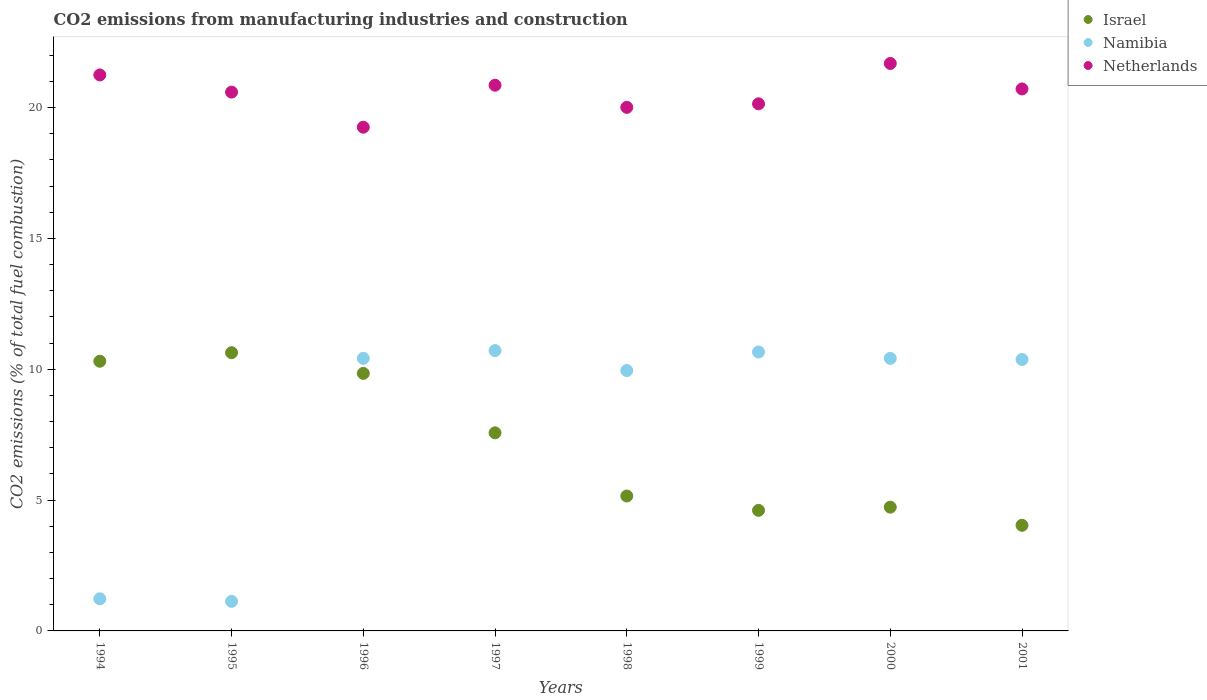How many different coloured dotlines are there?
Offer a terse response. 3. What is the amount of CO2 emitted in Netherlands in 2001?
Your answer should be very brief. 20.71. Across all years, what is the maximum amount of CO2 emitted in Israel?
Ensure brevity in your answer.  10.63. Across all years, what is the minimum amount of CO2 emitted in Israel?
Provide a short and direct response. 4.04. In which year was the amount of CO2 emitted in Israel maximum?
Offer a very short reply. 1995. What is the total amount of CO2 emitted in Israel in the graph?
Provide a succinct answer. 56.88. What is the difference between the amount of CO2 emitted in Israel in 1996 and that in 1999?
Your answer should be compact. 5.23. What is the difference between the amount of CO2 emitted in Namibia in 1995 and the amount of CO2 emitted in Netherlands in 1999?
Give a very brief answer. -19.01. What is the average amount of CO2 emitted in Israel per year?
Ensure brevity in your answer.  7.11. In the year 1997, what is the difference between the amount of CO2 emitted in Namibia and amount of CO2 emitted in Israel?
Ensure brevity in your answer.  3.14. What is the ratio of the amount of CO2 emitted in Namibia in 1995 to that in 2001?
Keep it short and to the point. 0.11. What is the difference between the highest and the second highest amount of CO2 emitted in Israel?
Your answer should be very brief. 0.33. What is the difference between the highest and the lowest amount of CO2 emitted in Netherlands?
Offer a terse response. 2.44. In how many years, is the amount of CO2 emitted in Israel greater than the average amount of CO2 emitted in Israel taken over all years?
Your answer should be very brief. 4. Is it the case that in every year, the sum of the amount of CO2 emitted in Netherlands and amount of CO2 emitted in Namibia  is greater than the amount of CO2 emitted in Israel?
Keep it short and to the point. Yes. Does the amount of CO2 emitted in Namibia monotonically increase over the years?
Your response must be concise. No. How many years are there in the graph?
Your answer should be compact. 8. Does the graph contain any zero values?
Your response must be concise. No. Where does the legend appear in the graph?
Provide a short and direct response. Top right. How many legend labels are there?
Make the answer very short. 3. What is the title of the graph?
Your answer should be very brief. CO2 emissions from manufacturing industries and construction. Does "South Sudan" appear as one of the legend labels in the graph?
Provide a succinct answer. No. What is the label or title of the Y-axis?
Offer a very short reply. CO2 emissions (% of total fuel combustion). What is the CO2 emissions (% of total fuel combustion) of Israel in 1994?
Make the answer very short. 10.31. What is the CO2 emissions (% of total fuel combustion) in Namibia in 1994?
Make the answer very short. 1.23. What is the CO2 emissions (% of total fuel combustion) in Netherlands in 1994?
Your response must be concise. 21.25. What is the CO2 emissions (% of total fuel combustion) of Israel in 1995?
Give a very brief answer. 10.63. What is the CO2 emissions (% of total fuel combustion) of Namibia in 1995?
Keep it short and to the point. 1.13. What is the CO2 emissions (% of total fuel combustion) in Netherlands in 1995?
Your answer should be very brief. 20.59. What is the CO2 emissions (% of total fuel combustion) in Israel in 1996?
Offer a very short reply. 9.84. What is the CO2 emissions (% of total fuel combustion) in Namibia in 1996?
Provide a short and direct response. 10.42. What is the CO2 emissions (% of total fuel combustion) of Netherlands in 1996?
Keep it short and to the point. 19.25. What is the CO2 emissions (% of total fuel combustion) of Israel in 1997?
Offer a very short reply. 7.57. What is the CO2 emissions (% of total fuel combustion) in Namibia in 1997?
Provide a succinct answer. 10.71. What is the CO2 emissions (% of total fuel combustion) in Netherlands in 1997?
Your answer should be compact. 20.86. What is the CO2 emissions (% of total fuel combustion) in Israel in 1998?
Keep it short and to the point. 5.16. What is the CO2 emissions (% of total fuel combustion) in Namibia in 1998?
Offer a terse response. 9.95. What is the CO2 emissions (% of total fuel combustion) of Netherlands in 1998?
Offer a terse response. 20.01. What is the CO2 emissions (% of total fuel combustion) in Israel in 1999?
Your answer should be very brief. 4.61. What is the CO2 emissions (% of total fuel combustion) of Namibia in 1999?
Give a very brief answer. 10.66. What is the CO2 emissions (% of total fuel combustion) in Netherlands in 1999?
Keep it short and to the point. 20.14. What is the CO2 emissions (% of total fuel combustion) in Israel in 2000?
Your answer should be compact. 4.73. What is the CO2 emissions (% of total fuel combustion) of Namibia in 2000?
Ensure brevity in your answer.  10.42. What is the CO2 emissions (% of total fuel combustion) of Netherlands in 2000?
Keep it short and to the point. 21.69. What is the CO2 emissions (% of total fuel combustion) in Israel in 2001?
Give a very brief answer. 4.04. What is the CO2 emissions (% of total fuel combustion) in Namibia in 2001?
Make the answer very short. 10.37. What is the CO2 emissions (% of total fuel combustion) in Netherlands in 2001?
Make the answer very short. 20.71. Across all years, what is the maximum CO2 emissions (% of total fuel combustion) of Israel?
Keep it short and to the point. 10.63. Across all years, what is the maximum CO2 emissions (% of total fuel combustion) in Namibia?
Offer a terse response. 10.71. Across all years, what is the maximum CO2 emissions (% of total fuel combustion) of Netherlands?
Ensure brevity in your answer.  21.69. Across all years, what is the minimum CO2 emissions (% of total fuel combustion) in Israel?
Ensure brevity in your answer.  4.04. Across all years, what is the minimum CO2 emissions (% of total fuel combustion) of Namibia?
Give a very brief answer. 1.13. Across all years, what is the minimum CO2 emissions (% of total fuel combustion) of Netherlands?
Offer a terse response. 19.25. What is the total CO2 emissions (% of total fuel combustion) in Israel in the graph?
Your answer should be compact. 56.88. What is the total CO2 emissions (% of total fuel combustion) in Namibia in the graph?
Your response must be concise. 64.89. What is the total CO2 emissions (% of total fuel combustion) in Netherlands in the graph?
Ensure brevity in your answer.  164.5. What is the difference between the CO2 emissions (% of total fuel combustion) of Israel in 1994 and that in 1995?
Provide a succinct answer. -0.33. What is the difference between the CO2 emissions (% of total fuel combustion) of Namibia in 1994 and that in 1995?
Your answer should be very brief. 0.1. What is the difference between the CO2 emissions (% of total fuel combustion) in Netherlands in 1994 and that in 1995?
Give a very brief answer. 0.66. What is the difference between the CO2 emissions (% of total fuel combustion) in Israel in 1994 and that in 1996?
Your response must be concise. 0.46. What is the difference between the CO2 emissions (% of total fuel combustion) in Namibia in 1994 and that in 1996?
Your answer should be very brief. -9.19. What is the difference between the CO2 emissions (% of total fuel combustion) of Netherlands in 1994 and that in 1996?
Offer a very short reply. 2. What is the difference between the CO2 emissions (% of total fuel combustion) in Israel in 1994 and that in 1997?
Offer a very short reply. 2.74. What is the difference between the CO2 emissions (% of total fuel combustion) of Namibia in 1994 and that in 1997?
Make the answer very short. -9.49. What is the difference between the CO2 emissions (% of total fuel combustion) of Netherlands in 1994 and that in 1997?
Provide a succinct answer. 0.39. What is the difference between the CO2 emissions (% of total fuel combustion) in Israel in 1994 and that in 1998?
Ensure brevity in your answer.  5.15. What is the difference between the CO2 emissions (% of total fuel combustion) in Namibia in 1994 and that in 1998?
Ensure brevity in your answer.  -8.72. What is the difference between the CO2 emissions (% of total fuel combustion) in Netherlands in 1994 and that in 1998?
Your answer should be very brief. 1.24. What is the difference between the CO2 emissions (% of total fuel combustion) of Israel in 1994 and that in 1999?
Give a very brief answer. 5.7. What is the difference between the CO2 emissions (% of total fuel combustion) of Namibia in 1994 and that in 1999?
Keep it short and to the point. -9.43. What is the difference between the CO2 emissions (% of total fuel combustion) of Netherlands in 1994 and that in 1999?
Your response must be concise. 1.1. What is the difference between the CO2 emissions (% of total fuel combustion) in Israel in 1994 and that in 2000?
Your answer should be compact. 5.58. What is the difference between the CO2 emissions (% of total fuel combustion) of Namibia in 1994 and that in 2000?
Provide a succinct answer. -9.19. What is the difference between the CO2 emissions (% of total fuel combustion) of Netherlands in 1994 and that in 2000?
Your answer should be compact. -0.44. What is the difference between the CO2 emissions (% of total fuel combustion) of Israel in 1994 and that in 2001?
Make the answer very short. 6.27. What is the difference between the CO2 emissions (% of total fuel combustion) of Namibia in 1994 and that in 2001?
Keep it short and to the point. -9.15. What is the difference between the CO2 emissions (% of total fuel combustion) in Netherlands in 1994 and that in 2001?
Ensure brevity in your answer.  0.54. What is the difference between the CO2 emissions (% of total fuel combustion) in Israel in 1995 and that in 1996?
Make the answer very short. 0.79. What is the difference between the CO2 emissions (% of total fuel combustion) in Namibia in 1995 and that in 1996?
Ensure brevity in your answer.  -9.29. What is the difference between the CO2 emissions (% of total fuel combustion) of Netherlands in 1995 and that in 1996?
Offer a very short reply. 1.34. What is the difference between the CO2 emissions (% of total fuel combustion) in Israel in 1995 and that in 1997?
Offer a terse response. 3.06. What is the difference between the CO2 emissions (% of total fuel combustion) of Namibia in 1995 and that in 1997?
Give a very brief answer. -9.58. What is the difference between the CO2 emissions (% of total fuel combustion) in Netherlands in 1995 and that in 1997?
Ensure brevity in your answer.  -0.26. What is the difference between the CO2 emissions (% of total fuel combustion) in Israel in 1995 and that in 1998?
Provide a short and direct response. 5.48. What is the difference between the CO2 emissions (% of total fuel combustion) of Namibia in 1995 and that in 1998?
Offer a terse response. -8.82. What is the difference between the CO2 emissions (% of total fuel combustion) in Netherlands in 1995 and that in 1998?
Ensure brevity in your answer.  0.58. What is the difference between the CO2 emissions (% of total fuel combustion) in Israel in 1995 and that in 1999?
Your answer should be very brief. 6.03. What is the difference between the CO2 emissions (% of total fuel combustion) of Namibia in 1995 and that in 1999?
Keep it short and to the point. -9.53. What is the difference between the CO2 emissions (% of total fuel combustion) in Netherlands in 1995 and that in 1999?
Provide a succinct answer. 0.45. What is the difference between the CO2 emissions (% of total fuel combustion) in Israel in 1995 and that in 2000?
Offer a terse response. 5.9. What is the difference between the CO2 emissions (% of total fuel combustion) of Namibia in 1995 and that in 2000?
Keep it short and to the point. -9.29. What is the difference between the CO2 emissions (% of total fuel combustion) in Netherlands in 1995 and that in 2000?
Make the answer very short. -1.09. What is the difference between the CO2 emissions (% of total fuel combustion) of Israel in 1995 and that in 2001?
Keep it short and to the point. 6.6. What is the difference between the CO2 emissions (% of total fuel combustion) in Namibia in 1995 and that in 2001?
Ensure brevity in your answer.  -9.24. What is the difference between the CO2 emissions (% of total fuel combustion) of Netherlands in 1995 and that in 2001?
Your answer should be very brief. -0.12. What is the difference between the CO2 emissions (% of total fuel combustion) in Israel in 1996 and that in 1997?
Offer a terse response. 2.27. What is the difference between the CO2 emissions (% of total fuel combustion) of Namibia in 1996 and that in 1997?
Your response must be concise. -0.3. What is the difference between the CO2 emissions (% of total fuel combustion) of Netherlands in 1996 and that in 1997?
Make the answer very short. -1.6. What is the difference between the CO2 emissions (% of total fuel combustion) of Israel in 1996 and that in 1998?
Your response must be concise. 4.69. What is the difference between the CO2 emissions (% of total fuel combustion) of Namibia in 1996 and that in 1998?
Offer a very short reply. 0.47. What is the difference between the CO2 emissions (% of total fuel combustion) in Netherlands in 1996 and that in 1998?
Make the answer very short. -0.76. What is the difference between the CO2 emissions (% of total fuel combustion) of Israel in 1996 and that in 1999?
Provide a succinct answer. 5.23. What is the difference between the CO2 emissions (% of total fuel combustion) in Namibia in 1996 and that in 1999?
Your response must be concise. -0.24. What is the difference between the CO2 emissions (% of total fuel combustion) in Netherlands in 1996 and that in 1999?
Ensure brevity in your answer.  -0.89. What is the difference between the CO2 emissions (% of total fuel combustion) of Israel in 1996 and that in 2000?
Offer a very short reply. 5.11. What is the difference between the CO2 emissions (% of total fuel combustion) in Netherlands in 1996 and that in 2000?
Offer a terse response. -2.44. What is the difference between the CO2 emissions (% of total fuel combustion) of Israel in 1996 and that in 2001?
Your response must be concise. 5.81. What is the difference between the CO2 emissions (% of total fuel combustion) in Namibia in 1996 and that in 2001?
Ensure brevity in your answer.  0.04. What is the difference between the CO2 emissions (% of total fuel combustion) in Netherlands in 1996 and that in 2001?
Give a very brief answer. -1.46. What is the difference between the CO2 emissions (% of total fuel combustion) in Israel in 1997 and that in 1998?
Make the answer very short. 2.41. What is the difference between the CO2 emissions (% of total fuel combustion) in Namibia in 1997 and that in 1998?
Give a very brief answer. 0.76. What is the difference between the CO2 emissions (% of total fuel combustion) in Netherlands in 1997 and that in 1998?
Give a very brief answer. 0.85. What is the difference between the CO2 emissions (% of total fuel combustion) of Israel in 1997 and that in 1999?
Offer a terse response. 2.96. What is the difference between the CO2 emissions (% of total fuel combustion) in Namibia in 1997 and that in 1999?
Ensure brevity in your answer.  0.05. What is the difference between the CO2 emissions (% of total fuel combustion) of Netherlands in 1997 and that in 1999?
Provide a short and direct response. 0.71. What is the difference between the CO2 emissions (% of total fuel combustion) of Israel in 1997 and that in 2000?
Your response must be concise. 2.84. What is the difference between the CO2 emissions (% of total fuel combustion) in Namibia in 1997 and that in 2000?
Ensure brevity in your answer.  0.3. What is the difference between the CO2 emissions (% of total fuel combustion) of Netherlands in 1997 and that in 2000?
Your response must be concise. -0.83. What is the difference between the CO2 emissions (% of total fuel combustion) of Israel in 1997 and that in 2001?
Ensure brevity in your answer.  3.53. What is the difference between the CO2 emissions (% of total fuel combustion) in Namibia in 1997 and that in 2001?
Make the answer very short. 0.34. What is the difference between the CO2 emissions (% of total fuel combustion) in Netherlands in 1997 and that in 2001?
Your answer should be very brief. 0.14. What is the difference between the CO2 emissions (% of total fuel combustion) in Israel in 1998 and that in 1999?
Your answer should be very brief. 0.55. What is the difference between the CO2 emissions (% of total fuel combustion) in Namibia in 1998 and that in 1999?
Your answer should be very brief. -0.71. What is the difference between the CO2 emissions (% of total fuel combustion) in Netherlands in 1998 and that in 1999?
Offer a terse response. -0.14. What is the difference between the CO2 emissions (% of total fuel combustion) in Israel in 1998 and that in 2000?
Make the answer very short. 0.43. What is the difference between the CO2 emissions (% of total fuel combustion) in Namibia in 1998 and that in 2000?
Your answer should be very brief. -0.47. What is the difference between the CO2 emissions (% of total fuel combustion) of Netherlands in 1998 and that in 2000?
Provide a succinct answer. -1.68. What is the difference between the CO2 emissions (% of total fuel combustion) in Israel in 1998 and that in 2001?
Ensure brevity in your answer.  1.12. What is the difference between the CO2 emissions (% of total fuel combustion) in Namibia in 1998 and that in 2001?
Provide a succinct answer. -0.42. What is the difference between the CO2 emissions (% of total fuel combustion) in Netherlands in 1998 and that in 2001?
Offer a terse response. -0.7. What is the difference between the CO2 emissions (% of total fuel combustion) of Israel in 1999 and that in 2000?
Keep it short and to the point. -0.12. What is the difference between the CO2 emissions (% of total fuel combustion) of Namibia in 1999 and that in 2000?
Keep it short and to the point. 0.24. What is the difference between the CO2 emissions (% of total fuel combustion) in Netherlands in 1999 and that in 2000?
Your answer should be compact. -1.54. What is the difference between the CO2 emissions (% of total fuel combustion) of Israel in 1999 and that in 2001?
Keep it short and to the point. 0.57. What is the difference between the CO2 emissions (% of total fuel combustion) of Namibia in 1999 and that in 2001?
Your response must be concise. 0.29. What is the difference between the CO2 emissions (% of total fuel combustion) of Netherlands in 1999 and that in 2001?
Give a very brief answer. -0.57. What is the difference between the CO2 emissions (% of total fuel combustion) in Israel in 2000 and that in 2001?
Your answer should be very brief. 0.69. What is the difference between the CO2 emissions (% of total fuel combustion) in Namibia in 2000 and that in 2001?
Offer a terse response. 0.04. What is the difference between the CO2 emissions (% of total fuel combustion) of Netherlands in 2000 and that in 2001?
Keep it short and to the point. 0.97. What is the difference between the CO2 emissions (% of total fuel combustion) in Israel in 1994 and the CO2 emissions (% of total fuel combustion) in Namibia in 1995?
Provide a succinct answer. 9.18. What is the difference between the CO2 emissions (% of total fuel combustion) in Israel in 1994 and the CO2 emissions (% of total fuel combustion) in Netherlands in 1995?
Make the answer very short. -10.29. What is the difference between the CO2 emissions (% of total fuel combustion) of Namibia in 1994 and the CO2 emissions (% of total fuel combustion) of Netherlands in 1995?
Offer a very short reply. -19.36. What is the difference between the CO2 emissions (% of total fuel combustion) of Israel in 1994 and the CO2 emissions (% of total fuel combustion) of Namibia in 1996?
Ensure brevity in your answer.  -0.11. What is the difference between the CO2 emissions (% of total fuel combustion) of Israel in 1994 and the CO2 emissions (% of total fuel combustion) of Netherlands in 1996?
Give a very brief answer. -8.94. What is the difference between the CO2 emissions (% of total fuel combustion) in Namibia in 1994 and the CO2 emissions (% of total fuel combustion) in Netherlands in 1996?
Offer a very short reply. -18.02. What is the difference between the CO2 emissions (% of total fuel combustion) in Israel in 1994 and the CO2 emissions (% of total fuel combustion) in Namibia in 1997?
Provide a succinct answer. -0.41. What is the difference between the CO2 emissions (% of total fuel combustion) of Israel in 1994 and the CO2 emissions (% of total fuel combustion) of Netherlands in 1997?
Keep it short and to the point. -10.55. What is the difference between the CO2 emissions (% of total fuel combustion) in Namibia in 1994 and the CO2 emissions (% of total fuel combustion) in Netherlands in 1997?
Your answer should be very brief. -19.63. What is the difference between the CO2 emissions (% of total fuel combustion) of Israel in 1994 and the CO2 emissions (% of total fuel combustion) of Namibia in 1998?
Ensure brevity in your answer.  0.36. What is the difference between the CO2 emissions (% of total fuel combustion) in Israel in 1994 and the CO2 emissions (% of total fuel combustion) in Netherlands in 1998?
Offer a terse response. -9.7. What is the difference between the CO2 emissions (% of total fuel combustion) of Namibia in 1994 and the CO2 emissions (% of total fuel combustion) of Netherlands in 1998?
Make the answer very short. -18.78. What is the difference between the CO2 emissions (% of total fuel combustion) in Israel in 1994 and the CO2 emissions (% of total fuel combustion) in Namibia in 1999?
Your answer should be compact. -0.35. What is the difference between the CO2 emissions (% of total fuel combustion) in Israel in 1994 and the CO2 emissions (% of total fuel combustion) in Netherlands in 1999?
Give a very brief answer. -9.84. What is the difference between the CO2 emissions (% of total fuel combustion) of Namibia in 1994 and the CO2 emissions (% of total fuel combustion) of Netherlands in 1999?
Keep it short and to the point. -18.92. What is the difference between the CO2 emissions (% of total fuel combustion) of Israel in 1994 and the CO2 emissions (% of total fuel combustion) of Namibia in 2000?
Your answer should be very brief. -0.11. What is the difference between the CO2 emissions (% of total fuel combustion) of Israel in 1994 and the CO2 emissions (% of total fuel combustion) of Netherlands in 2000?
Provide a short and direct response. -11.38. What is the difference between the CO2 emissions (% of total fuel combustion) of Namibia in 1994 and the CO2 emissions (% of total fuel combustion) of Netherlands in 2000?
Offer a very short reply. -20.46. What is the difference between the CO2 emissions (% of total fuel combustion) of Israel in 1994 and the CO2 emissions (% of total fuel combustion) of Namibia in 2001?
Provide a short and direct response. -0.07. What is the difference between the CO2 emissions (% of total fuel combustion) in Israel in 1994 and the CO2 emissions (% of total fuel combustion) in Netherlands in 2001?
Provide a short and direct response. -10.41. What is the difference between the CO2 emissions (% of total fuel combustion) of Namibia in 1994 and the CO2 emissions (% of total fuel combustion) of Netherlands in 2001?
Offer a terse response. -19.49. What is the difference between the CO2 emissions (% of total fuel combustion) in Israel in 1995 and the CO2 emissions (% of total fuel combustion) in Namibia in 1996?
Give a very brief answer. 0.22. What is the difference between the CO2 emissions (% of total fuel combustion) of Israel in 1995 and the CO2 emissions (% of total fuel combustion) of Netherlands in 1996?
Your answer should be very brief. -8.62. What is the difference between the CO2 emissions (% of total fuel combustion) in Namibia in 1995 and the CO2 emissions (% of total fuel combustion) in Netherlands in 1996?
Provide a short and direct response. -18.12. What is the difference between the CO2 emissions (% of total fuel combustion) in Israel in 1995 and the CO2 emissions (% of total fuel combustion) in Namibia in 1997?
Your answer should be very brief. -0.08. What is the difference between the CO2 emissions (% of total fuel combustion) in Israel in 1995 and the CO2 emissions (% of total fuel combustion) in Netherlands in 1997?
Your answer should be compact. -10.22. What is the difference between the CO2 emissions (% of total fuel combustion) of Namibia in 1995 and the CO2 emissions (% of total fuel combustion) of Netherlands in 1997?
Provide a succinct answer. -19.73. What is the difference between the CO2 emissions (% of total fuel combustion) in Israel in 1995 and the CO2 emissions (% of total fuel combustion) in Namibia in 1998?
Keep it short and to the point. 0.68. What is the difference between the CO2 emissions (% of total fuel combustion) of Israel in 1995 and the CO2 emissions (% of total fuel combustion) of Netherlands in 1998?
Your answer should be very brief. -9.38. What is the difference between the CO2 emissions (% of total fuel combustion) in Namibia in 1995 and the CO2 emissions (% of total fuel combustion) in Netherlands in 1998?
Offer a very short reply. -18.88. What is the difference between the CO2 emissions (% of total fuel combustion) of Israel in 1995 and the CO2 emissions (% of total fuel combustion) of Namibia in 1999?
Provide a succinct answer. -0.03. What is the difference between the CO2 emissions (% of total fuel combustion) of Israel in 1995 and the CO2 emissions (% of total fuel combustion) of Netherlands in 1999?
Your response must be concise. -9.51. What is the difference between the CO2 emissions (% of total fuel combustion) of Namibia in 1995 and the CO2 emissions (% of total fuel combustion) of Netherlands in 1999?
Your answer should be very brief. -19.01. What is the difference between the CO2 emissions (% of total fuel combustion) in Israel in 1995 and the CO2 emissions (% of total fuel combustion) in Namibia in 2000?
Your response must be concise. 0.22. What is the difference between the CO2 emissions (% of total fuel combustion) of Israel in 1995 and the CO2 emissions (% of total fuel combustion) of Netherlands in 2000?
Offer a very short reply. -11.05. What is the difference between the CO2 emissions (% of total fuel combustion) in Namibia in 1995 and the CO2 emissions (% of total fuel combustion) in Netherlands in 2000?
Ensure brevity in your answer.  -20.56. What is the difference between the CO2 emissions (% of total fuel combustion) in Israel in 1995 and the CO2 emissions (% of total fuel combustion) in Namibia in 2001?
Provide a short and direct response. 0.26. What is the difference between the CO2 emissions (% of total fuel combustion) in Israel in 1995 and the CO2 emissions (% of total fuel combustion) in Netherlands in 2001?
Your answer should be very brief. -10.08. What is the difference between the CO2 emissions (% of total fuel combustion) of Namibia in 1995 and the CO2 emissions (% of total fuel combustion) of Netherlands in 2001?
Ensure brevity in your answer.  -19.58. What is the difference between the CO2 emissions (% of total fuel combustion) in Israel in 1996 and the CO2 emissions (% of total fuel combustion) in Namibia in 1997?
Offer a terse response. -0.87. What is the difference between the CO2 emissions (% of total fuel combustion) of Israel in 1996 and the CO2 emissions (% of total fuel combustion) of Netherlands in 1997?
Your answer should be very brief. -11.01. What is the difference between the CO2 emissions (% of total fuel combustion) of Namibia in 1996 and the CO2 emissions (% of total fuel combustion) of Netherlands in 1997?
Give a very brief answer. -10.44. What is the difference between the CO2 emissions (% of total fuel combustion) in Israel in 1996 and the CO2 emissions (% of total fuel combustion) in Namibia in 1998?
Offer a very short reply. -0.11. What is the difference between the CO2 emissions (% of total fuel combustion) in Israel in 1996 and the CO2 emissions (% of total fuel combustion) in Netherlands in 1998?
Provide a short and direct response. -10.17. What is the difference between the CO2 emissions (% of total fuel combustion) in Namibia in 1996 and the CO2 emissions (% of total fuel combustion) in Netherlands in 1998?
Keep it short and to the point. -9.59. What is the difference between the CO2 emissions (% of total fuel combustion) of Israel in 1996 and the CO2 emissions (% of total fuel combustion) of Namibia in 1999?
Ensure brevity in your answer.  -0.82. What is the difference between the CO2 emissions (% of total fuel combustion) in Israel in 1996 and the CO2 emissions (% of total fuel combustion) in Netherlands in 1999?
Your response must be concise. -10.3. What is the difference between the CO2 emissions (% of total fuel combustion) in Namibia in 1996 and the CO2 emissions (% of total fuel combustion) in Netherlands in 1999?
Provide a short and direct response. -9.73. What is the difference between the CO2 emissions (% of total fuel combustion) of Israel in 1996 and the CO2 emissions (% of total fuel combustion) of Namibia in 2000?
Offer a terse response. -0.57. What is the difference between the CO2 emissions (% of total fuel combustion) in Israel in 1996 and the CO2 emissions (% of total fuel combustion) in Netherlands in 2000?
Provide a short and direct response. -11.84. What is the difference between the CO2 emissions (% of total fuel combustion) of Namibia in 1996 and the CO2 emissions (% of total fuel combustion) of Netherlands in 2000?
Give a very brief answer. -11.27. What is the difference between the CO2 emissions (% of total fuel combustion) in Israel in 1996 and the CO2 emissions (% of total fuel combustion) in Namibia in 2001?
Provide a succinct answer. -0.53. What is the difference between the CO2 emissions (% of total fuel combustion) in Israel in 1996 and the CO2 emissions (% of total fuel combustion) in Netherlands in 2001?
Your answer should be very brief. -10.87. What is the difference between the CO2 emissions (% of total fuel combustion) of Namibia in 1996 and the CO2 emissions (% of total fuel combustion) of Netherlands in 2001?
Offer a terse response. -10.3. What is the difference between the CO2 emissions (% of total fuel combustion) of Israel in 1997 and the CO2 emissions (% of total fuel combustion) of Namibia in 1998?
Offer a very short reply. -2.38. What is the difference between the CO2 emissions (% of total fuel combustion) in Israel in 1997 and the CO2 emissions (% of total fuel combustion) in Netherlands in 1998?
Your answer should be very brief. -12.44. What is the difference between the CO2 emissions (% of total fuel combustion) of Namibia in 1997 and the CO2 emissions (% of total fuel combustion) of Netherlands in 1998?
Provide a succinct answer. -9.29. What is the difference between the CO2 emissions (% of total fuel combustion) in Israel in 1997 and the CO2 emissions (% of total fuel combustion) in Namibia in 1999?
Ensure brevity in your answer.  -3.09. What is the difference between the CO2 emissions (% of total fuel combustion) in Israel in 1997 and the CO2 emissions (% of total fuel combustion) in Netherlands in 1999?
Provide a short and direct response. -12.57. What is the difference between the CO2 emissions (% of total fuel combustion) in Namibia in 1997 and the CO2 emissions (% of total fuel combustion) in Netherlands in 1999?
Provide a short and direct response. -9.43. What is the difference between the CO2 emissions (% of total fuel combustion) of Israel in 1997 and the CO2 emissions (% of total fuel combustion) of Namibia in 2000?
Keep it short and to the point. -2.85. What is the difference between the CO2 emissions (% of total fuel combustion) in Israel in 1997 and the CO2 emissions (% of total fuel combustion) in Netherlands in 2000?
Ensure brevity in your answer.  -14.12. What is the difference between the CO2 emissions (% of total fuel combustion) in Namibia in 1997 and the CO2 emissions (% of total fuel combustion) in Netherlands in 2000?
Your answer should be very brief. -10.97. What is the difference between the CO2 emissions (% of total fuel combustion) of Israel in 1997 and the CO2 emissions (% of total fuel combustion) of Namibia in 2001?
Make the answer very short. -2.8. What is the difference between the CO2 emissions (% of total fuel combustion) in Israel in 1997 and the CO2 emissions (% of total fuel combustion) in Netherlands in 2001?
Give a very brief answer. -13.14. What is the difference between the CO2 emissions (% of total fuel combustion) in Namibia in 1997 and the CO2 emissions (% of total fuel combustion) in Netherlands in 2001?
Offer a very short reply. -10. What is the difference between the CO2 emissions (% of total fuel combustion) of Israel in 1998 and the CO2 emissions (% of total fuel combustion) of Namibia in 1999?
Keep it short and to the point. -5.5. What is the difference between the CO2 emissions (% of total fuel combustion) in Israel in 1998 and the CO2 emissions (% of total fuel combustion) in Netherlands in 1999?
Provide a short and direct response. -14.99. What is the difference between the CO2 emissions (% of total fuel combustion) of Namibia in 1998 and the CO2 emissions (% of total fuel combustion) of Netherlands in 1999?
Your answer should be very brief. -10.19. What is the difference between the CO2 emissions (% of total fuel combustion) of Israel in 1998 and the CO2 emissions (% of total fuel combustion) of Namibia in 2000?
Keep it short and to the point. -5.26. What is the difference between the CO2 emissions (% of total fuel combustion) of Israel in 1998 and the CO2 emissions (% of total fuel combustion) of Netherlands in 2000?
Your answer should be very brief. -16.53. What is the difference between the CO2 emissions (% of total fuel combustion) in Namibia in 1998 and the CO2 emissions (% of total fuel combustion) in Netherlands in 2000?
Make the answer very short. -11.74. What is the difference between the CO2 emissions (% of total fuel combustion) of Israel in 1998 and the CO2 emissions (% of total fuel combustion) of Namibia in 2001?
Keep it short and to the point. -5.22. What is the difference between the CO2 emissions (% of total fuel combustion) in Israel in 1998 and the CO2 emissions (% of total fuel combustion) in Netherlands in 2001?
Your answer should be very brief. -15.56. What is the difference between the CO2 emissions (% of total fuel combustion) of Namibia in 1998 and the CO2 emissions (% of total fuel combustion) of Netherlands in 2001?
Your answer should be compact. -10.76. What is the difference between the CO2 emissions (% of total fuel combustion) in Israel in 1999 and the CO2 emissions (% of total fuel combustion) in Namibia in 2000?
Make the answer very short. -5.81. What is the difference between the CO2 emissions (% of total fuel combustion) in Israel in 1999 and the CO2 emissions (% of total fuel combustion) in Netherlands in 2000?
Your answer should be very brief. -17.08. What is the difference between the CO2 emissions (% of total fuel combustion) of Namibia in 1999 and the CO2 emissions (% of total fuel combustion) of Netherlands in 2000?
Your answer should be compact. -11.03. What is the difference between the CO2 emissions (% of total fuel combustion) in Israel in 1999 and the CO2 emissions (% of total fuel combustion) in Namibia in 2001?
Provide a succinct answer. -5.77. What is the difference between the CO2 emissions (% of total fuel combustion) in Israel in 1999 and the CO2 emissions (% of total fuel combustion) in Netherlands in 2001?
Give a very brief answer. -16.1. What is the difference between the CO2 emissions (% of total fuel combustion) in Namibia in 1999 and the CO2 emissions (% of total fuel combustion) in Netherlands in 2001?
Your response must be concise. -10.05. What is the difference between the CO2 emissions (% of total fuel combustion) in Israel in 2000 and the CO2 emissions (% of total fuel combustion) in Namibia in 2001?
Offer a very short reply. -5.64. What is the difference between the CO2 emissions (% of total fuel combustion) in Israel in 2000 and the CO2 emissions (% of total fuel combustion) in Netherlands in 2001?
Your response must be concise. -15.98. What is the difference between the CO2 emissions (% of total fuel combustion) of Namibia in 2000 and the CO2 emissions (% of total fuel combustion) of Netherlands in 2001?
Offer a terse response. -10.3. What is the average CO2 emissions (% of total fuel combustion) of Israel per year?
Provide a succinct answer. 7.11. What is the average CO2 emissions (% of total fuel combustion) of Namibia per year?
Make the answer very short. 8.11. What is the average CO2 emissions (% of total fuel combustion) of Netherlands per year?
Provide a short and direct response. 20.56. In the year 1994, what is the difference between the CO2 emissions (% of total fuel combustion) of Israel and CO2 emissions (% of total fuel combustion) of Namibia?
Provide a succinct answer. 9.08. In the year 1994, what is the difference between the CO2 emissions (% of total fuel combustion) in Israel and CO2 emissions (% of total fuel combustion) in Netherlands?
Your response must be concise. -10.94. In the year 1994, what is the difference between the CO2 emissions (% of total fuel combustion) in Namibia and CO2 emissions (% of total fuel combustion) in Netherlands?
Make the answer very short. -20.02. In the year 1995, what is the difference between the CO2 emissions (% of total fuel combustion) in Israel and CO2 emissions (% of total fuel combustion) in Namibia?
Your answer should be very brief. 9.5. In the year 1995, what is the difference between the CO2 emissions (% of total fuel combustion) in Israel and CO2 emissions (% of total fuel combustion) in Netherlands?
Offer a very short reply. -9.96. In the year 1995, what is the difference between the CO2 emissions (% of total fuel combustion) of Namibia and CO2 emissions (% of total fuel combustion) of Netherlands?
Ensure brevity in your answer.  -19.46. In the year 1996, what is the difference between the CO2 emissions (% of total fuel combustion) in Israel and CO2 emissions (% of total fuel combustion) in Namibia?
Provide a succinct answer. -0.57. In the year 1996, what is the difference between the CO2 emissions (% of total fuel combustion) of Israel and CO2 emissions (% of total fuel combustion) of Netherlands?
Provide a succinct answer. -9.41. In the year 1996, what is the difference between the CO2 emissions (% of total fuel combustion) of Namibia and CO2 emissions (% of total fuel combustion) of Netherlands?
Make the answer very short. -8.83. In the year 1997, what is the difference between the CO2 emissions (% of total fuel combustion) of Israel and CO2 emissions (% of total fuel combustion) of Namibia?
Give a very brief answer. -3.14. In the year 1997, what is the difference between the CO2 emissions (% of total fuel combustion) of Israel and CO2 emissions (% of total fuel combustion) of Netherlands?
Provide a succinct answer. -13.29. In the year 1997, what is the difference between the CO2 emissions (% of total fuel combustion) in Namibia and CO2 emissions (% of total fuel combustion) in Netherlands?
Your answer should be very brief. -10.14. In the year 1998, what is the difference between the CO2 emissions (% of total fuel combustion) of Israel and CO2 emissions (% of total fuel combustion) of Namibia?
Keep it short and to the point. -4.79. In the year 1998, what is the difference between the CO2 emissions (% of total fuel combustion) of Israel and CO2 emissions (% of total fuel combustion) of Netherlands?
Give a very brief answer. -14.85. In the year 1998, what is the difference between the CO2 emissions (% of total fuel combustion) in Namibia and CO2 emissions (% of total fuel combustion) in Netherlands?
Your answer should be compact. -10.06. In the year 1999, what is the difference between the CO2 emissions (% of total fuel combustion) of Israel and CO2 emissions (% of total fuel combustion) of Namibia?
Provide a succinct answer. -6.05. In the year 1999, what is the difference between the CO2 emissions (% of total fuel combustion) of Israel and CO2 emissions (% of total fuel combustion) of Netherlands?
Make the answer very short. -15.54. In the year 1999, what is the difference between the CO2 emissions (% of total fuel combustion) in Namibia and CO2 emissions (% of total fuel combustion) in Netherlands?
Ensure brevity in your answer.  -9.48. In the year 2000, what is the difference between the CO2 emissions (% of total fuel combustion) of Israel and CO2 emissions (% of total fuel combustion) of Namibia?
Your answer should be compact. -5.69. In the year 2000, what is the difference between the CO2 emissions (% of total fuel combustion) of Israel and CO2 emissions (% of total fuel combustion) of Netherlands?
Your answer should be compact. -16.96. In the year 2000, what is the difference between the CO2 emissions (% of total fuel combustion) of Namibia and CO2 emissions (% of total fuel combustion) of Netherlands?
Your answer should be very brief. -11.27. In the year 2001, what is the difference between the CO2 emissions (% of total fuel combustion) of Israel and CO2 emissions (% of total fuel combustion) of Namibia?
Provide a short and direct response. -6.34. In the year 2001, what is the difference between the CO2 emissions (% of total fuel combustion) in Israel and CO2 emissions (% of total fuel combustion) in Netherlands?
Your response must be concise. -16.68. In the year 2001, what is the difference between the CO2 emissions (% of total fuel combustion) in Namibia and CO2 emissions (% of total fuel combustion) in Netherlands?
Give a very brief answer. -10.34. What is the ratio of the CO2 emissions (% of total fuel combustion) in Israel in 1994 to that in 1995?
Keep it short and to the point. 0.97. What is the ratio of the CO2 emissions (% of total fuel combustion) of Namibia in 1994 to that in 1995?
Your answer should be compact. 1.09. What is the ratio of the CO2 emissions (% of total fuel combustion) of Netherlands in 1994 to that in 1995?
Offer a terse response. 1.03. What is the ratio of the CO2 emissions (% of total fuel combustion) in Israel in 1994 to that in 1996?
Make the answer very short. 1.05. What is the ratio of the CO2 emissions (% of total fuel combustion) of Namibia in 1994 to that in 1996?
Your answer should be compact. 0.12. What is the ratio of the CO2 emissions (% of total fuel combustion) of Netherlands in 1994 to that in 1996?
Your answer should be very brief. 1.1. What is the ratio of the CO2 emissions (% of total fuel combustion) of Israel in 1994 to that in 1997?
Ensure brevity in your answer.  1.36. What is the ratio of the CO2 emissions (% of total fuel combustion) in Namibia in 1994 to that in 1997?
Keep it short and to the point. 0.11. What is the ratio of the CO2 emissions (% of total fuel combustion) in Netherlands in 1994 to that in 1997?
Your answer should be very brief. 1.02. What is the ratio of the CO2 emissions (% of total fuel combustion) of Israel in 1994 to that in 1998?
Make the answer very short. 2. What is the ratio of the CO2 emissions (% of total fuel combustion) in Namibia in 1994 to that in 1998?
Keep it short and to the point. 0.12. What is the ratio of the CO2 emissions (% of total fuel combustion) of Netherlands in 1994 to that in 1998?
Provide a succinct answer. 1.06. What is the ratio of the CO2 emissions (% of total fuel combustion) in Israel in 1994 to that in 1999?
Your answer should be compact. 2.24. What is the ratio of the CO2 emissions (% of total fuel combustion) of Namibia in 1994 to that in 1999?
Your answer should be compact. 0.12. What is the ratio of the CO2 emissions (% of total fuel combustion) of Netherlands in 1994 to that in 1999?
Your answer should be very brief. 1.05. What is the ratio of the CO2 emissions (% of total fuel combustion) of Israel in 1994 to that in 2000?
Give a very brief answer. 2.18. What is the ratio of the CO2 emissions (% of total fuel combustion) in Namibia in 1994 to that in 2000?
Make the answer very short. 0.12. What is the ratio of the CO2 emissions (% of total fuel combustion) in Netherlands in 1994 to that in 2000?
Your response must be concise. 0.98. What is the ratio of the CO2 emissions (% of total fuel combustion) in Israel in 1994 to that in 2001?
Offer a terse response. 2.55. What is the ratio of the CO2 emissions (% of total fuel combustion) of Namibia in 1994 to that in 2001?
Give a very brief answer. 0.12. What is the ratio of the CO2 emissions (% of total fuel combustion) of Netherlands in 1994 to that in 2001?
Offer a terse response. 1.03. What is the ratio of the CO2 emissions (% of total fuel combustion) in Israel in 1995 to that in 1996?
Provide a short and direct response. 1.08. What is the ratio of the CO2 emissions (% of total fuel combustion) of Namibia in 1995 to that in 1996?
Your answer should be compact. 0.11. What is the ratio of the CO2 emissions (% of total fuel combustion) of Netherlands in 1995 to that in 1996?
Make the answer very short. 1.07. What is the ratio of the CO2 emissions (% of total fuel combustion) in Israel in 1995 to that in 1997?
Your response must be concise. 1.4. What is the ratio of the CO2 emissions (% of total fuel combustion) of Namibia in 1995 to that in 1997?
Offer a very short reply. 0.11. What is the ratio of the CO2 emissions (% of total fuel combustion) of Netherlands in 1995 to that in 1997?
Your response must be concise. 0.99. What is the ratio of the CO2 emissions (% of total fuel combustion) of Israel in 1995 to that in 1998?
Make the answer very short. 2.06. What is the ratio of the CO2 emissions (% of total fuel combustion) in Namibia in 1995 to that in 1998?
Your answer should be compact. 0.11. What is the ratio of the CO2 emissions (% of total fuel combustion) in Netherlands in 1995 to that in 1998?
Provide a succinct answer. 1.03. What is the ratio of the CO2 emissions (% of total fuel combustion) of Israel in 1995 to that in 1999?
Give a very brief answer. 2.31. What is the ratio of the CO2 emissions (% of total fuel combustion) in Namibia in 1995 to that in 1999?
Ensure brevity in your answer.  0.11. What is the ratio of the CO2 emissions (% of total fuel combustion) of Netherlands in 1995 to that in 1999?
Provide a short and direct response. 1.02. What is the ratio of the CO2 emissions (% of total fuel combustion) in Israel in 1995 to that in 2000?
Offer a very short reply. 2.25. What is the ratio of the CO2 emissions (% of total fuel combustion) in Namibia in 1995 to that in 2000?
Offer a very short reply. 0.11. What is the ratio of the CO2 emissions (% of total fuel combustion) in Netherlands in 1995 to that in 2000?
Keep it short and to the point. 0.95. What is the ratio of the CO2 emissions (% of total fuel combustion) of Israel in 1995 to that in 2001?
Ensure brevity in your answer.  2.63. What is the ratio of the CO2 emissions (% of total fuel combustion) in Namibia in 1995 to that in 2001?
Your answer should be very brief. 0.11. What is the ratio of the CO2 emissions (% of total fuel combustion) of Israel in 1996 to that in 1997?
Keep it short and to the point. 1.3. What is the ratio of the CO2 emissions (% of total fuel combustion) in Namibia in 1996 to that in 1997?
Your response must be concise. 0.97. What is the ratio of the CO2 emissions (% of total fuel combustion) of Netherlands in 1996 to that in 1997?
Keep it short and to the point. 0.92. What is the ratio of the CO2 emissions (% of total fuel combustion) of Israel in 1996 to that in 1998?
Ensure brevity in your answer.  1.91. What is the ratio of the CO2 emissions (% of total fuel combustion) of Namibia in 1996 to that in 1998?
Ensure brevity in your answer.  1.05. What is the ratio of the CO2 emissions (% of total fuel combustion) of Netherlands in 1996 to that in 1998?
Provide a succinct answer. 0.96. What is the ratio of the CO2 emissions (% of total fuel combustion) of Israel in 1996 to that in 1999?
Give a very brief answer. 2.14. What is the ratio of the CO2 emissions (% of total fuel combustion) of Namibia in 1996 to that in 1999?
Ensure brevity in your answer.  0.98. What is the ratio of the CO2 emissions (% of total fuel combustion) of Netherlands in 1996 to that in 1999?
Your answer should be very brief. 0.96. What is the ratio of the CO2 emissions (% of total fuel combustion) in Israel in 1996 to that in 2000?
Make the answer very short. 2.08. What is the ratio of the CO2 emissions (% of total fuel combustion) of Namibia in 1996 to that in 2000?
Offer a very short reply. 1. What is the ratio of the CO2 emissions (% of total fuel combustion) in Netherlands in 1996 to that in 2000?
Provide a succinct answer. 0.89. What is the ratio of the CO2 emissions (% of total fuel combustion) in Israel in 1996 to that in 2001?
Offer a very short reply. 2.44. What is the ratio of the CO2 emissions (% of total fuel combustion) of Namibia in 1996 to that in 2001?
Your response must be concise. 1. What is the ratio of the CO2 emissions (% of total fuel combustion) in Netherlands in 1996 to that in 2001?
Your answer should be compact. 0.93. What is the ratio of the CO2 emissions (% of total fuel combustion) of Israel in 1997 to that in 1998?
Your answer should be compact. 1.47. What is the ratio of the CO2 emissions (% of total fuel combustion) of Namibia in 1997 to that in 1998?
Your answer should be compact. 1.08. What is the ratio of the CO2 emissions (% of total fuel combustion) of Netherlands in 1997 to that in 1998?
Provide a short and direct response. 1.04. What is the ratio of the CO2 emissions (% of total fuel combustion) in Israel in 1997 to that in 1999?
Provide a short and direct response. 1.64. What is the ratio of the CO2 emissions (% of total fuel combustion) in Netherlands in 1997 to that in 1999?
Provide a short and direct response. 1.04. What is the ratio of the CO2 emissions (% of total fuel combustion) in Israel in 1997 to that in 2000?
Your response must be concise. 1.6. What is the ratio of the CO2 emissions (% of total fuel combustion) in Namibia in 1997 to that in 2000?
Keep it short and to the point. 1.03. What is the ratio of the CO2 emissions (% of total fuel combustion) in Netherlands in 1997 to that in 2000?
Your answer should be compact. 0.96. What is the ratio of the CO2 emissions (% of total fuel combustion) in Israel in 1997 to that in 2001?
Give a very brief answer. 1.88. What is the ratio of the CO2 emissions (% of total fuel combustion) of Namibia in 1997 to that in 2001?
Make the answer very short. 1.03. What is the ratio of the CO2 emissions (% of total fuel combustion) of Israel in 1998 to that in 1999?
Ensure brevity in your answer.  1.12. What is the ratio of the CO2 emissions (% of total fuel combustion) of Namibia in 1998 to that in 1999?
Make the answer very short. 0.93. What is the ratio of the CO2 emissions (% of total fuel combustion) in Netherlands in 1998 to that in 1999?
Ensure brevity in your answer.  0.99. What is the ratio of the CO2 emissions (% of total fuel combustion) of Israel in 1998 to that in 2000?
Make the answer very short. 1.09. What is the ratio of the CO2 emissions (% of total fuel combustion) of Namibia in 1998 to that in 2000?
Keep it short and to the point. 0.96. What is the ratio of the CO2 emissions (% of total fuel combustion) in Netherlands in 1998 to that in 2000?
Provide a short and direct response. 0.92. What is the ratio of the CO2 emissions (% of total fuel combustion) in Israel in 1998 to that in 2001?
Give a very brief answer. 1.28. What is the ratio of the CO2 emissions (% of total fuel combustion) of Namibia in 1998 to that in 2001?
Offer a terse response. 0.96. What is the ratio of the CO2 emissions (% of total fuel combustion) in Israel in 1999 to that in 2000?
Keep it short and to the point. 0.97. What is the ratio of the CO2 emissions (% of total fuel combustion) of Namibia in 1999 to that in 2000?
Your response must be concise. 1.02. What is the ratio of the CO2 emissions (% of total fuel combustion) in Netherlands in 1999 to that in 2000?
Ensure brevity in your answer.  0.93. What is the ratio of the CO2 emissions (% of total fuel combustion) of Israel in 1999 to that in 2001?
Give a very brief answer. 1.14. What is the ratio of the CO2 emissions (% of total fuel combustion) of Namibia in 1999 to that in 2001?
Give a very brief answer. 1.03. What is the ratio of the CO2 emissions (% of total fuel combustion) of Netherlands in 1999 to that in 2001?
Offer a terse response. 0.97. What is the ratio of the CO2 emissions (% of total fuel combustion) of Israel in 2000 to that in 2001?
Offer a very short reply. 1.17. What is the ratio of the CO2 emissions (% of total fuel combustion) of Namibia in 2000 to that in 2001?
Keep it short and to the point. 1. What is the ratio of the CO2 emissions (% of total fuel combustion) of Netherlands in 2000 to that in 2001?
Your answer should be very brief. 1.05. What is the difference between the highest and the second highest CO2 emissions (% of total fuel combustion) of Israel?
Offer a terse response. 0.33. What is the difference between the highest and the second highest CO2 emissions (% of total fuel combustion) in Namibia?
Provide a succinct answer. 0.05. What is the difference between the highest and the second highest CO2 emissions (% of total fuel combustion) of Netherlands?
Ensure brevity in your answer.  0.44. What is the difference between the highest and the lowest CO2 emissions (% of total fuel combustion) in Israel?
Offer a terse response. 6.6. What is the difference between the highest and the lowest CO2 emissions (% of total fuel combustion) in Namibia?
Provide a short and direct response. 9.58. What is the difference between the highest and the lowest CO2 emissions (% of total fuel combustion) of Netherlands?
Make the answer very short. 2.44. 